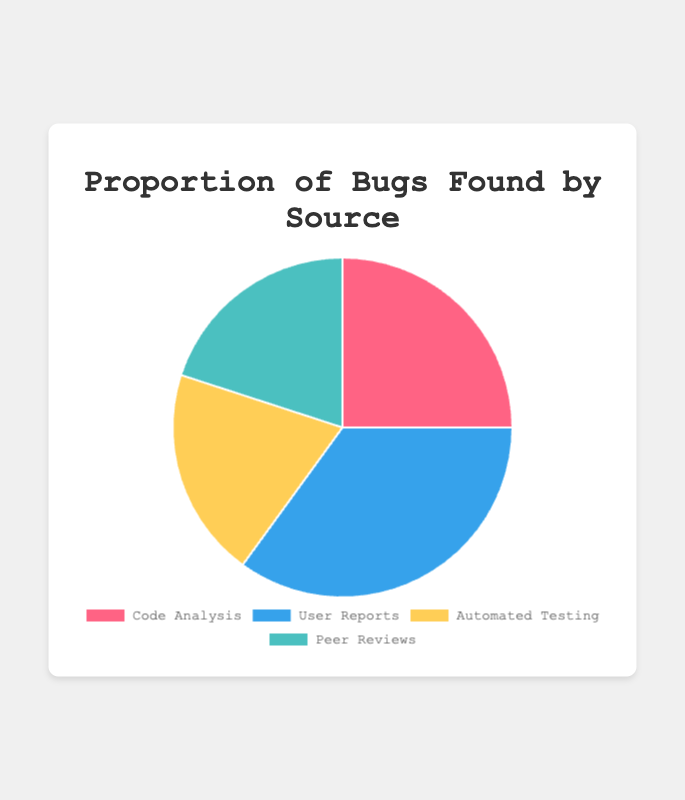What proportion of bugs is found by User Reports? User Reports account for 35% of the bugs found. This information is directly given in the data and represented in the pie chart.
Answer: 35% Which sources contribute equally to the proportion of bugs found? Both Automated Testing and Peer Reviews contribute equally, each accounting for 20% of the bugs found. This is visible from the equal-sized segments on the pie chart.
Answer: Automated Testing and Peer Reviews How much greater is the proportion of bugs found by User Reports compared to those found by Automated Testing? User Reports show 35% while Automated Testing shows 20%. Subtracting 20 from 35 gives us 15%. So, User Reports find 15% more bugs than Automated Testing.
Answer: 15% Is the proportion of bugs found by Code Analysis greater than that found by Peer Reviews? Code Analysis accounts for 25% while Peer Reviews account for 20%. Since 25 is greater than 20, the answer is yes.
Answer: Yes What is the combined proportion of bugs found by Automated Testing and Peer Reviews? Automated Testing finds 20% and Peer Reviews find 20%. Adding these together, we get 20% + 20% = 40%.
Answer: 40% Which source is represented by the largest segment in the pie chart? The User Reports segment is the largest, indicating a 35% proportion, which is visibly larger than the other segments.
Answer: User Reports What proportion of bugs is found by Code Analysis and Peer Reviews combined? Code Analysis accounts for 25% and Peer Reviews account for 20%. Adding these together, 25% + 20%, gives us a total of 45%.
Answer: 45% What is the difference in the proportion of bugs found between User Reports and Code Analysis? User Reports account for 35% and Code Analysis accounts for 25%. The difference between these proportions is 35% - 25% = 10%.
Answer: 10% How many segments in the pie chart have a proportion of 20%? Two segments, Automated Testing and Peer Reviews, each account for 20% in the pie chart.
Answer: 2 segments What is the average proportion of bugs found across all sources? The proportions given are 25%, 35%, 20%, and 20%. Adding these together gives 25 + 35 + 20 + 20 = 100. Dividing by the number of sources, 100 / 4 gives an average of 25%.
Answer: 25% 